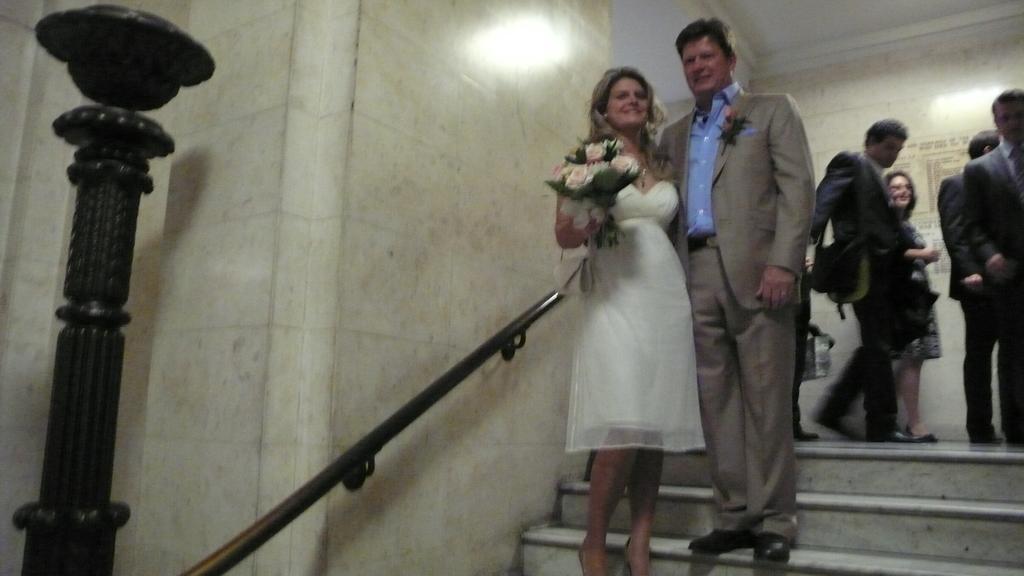Could you give a brief overview of what you see in this image? In this image in the front there are persons standing and smiling. On the left side there is a pole. In the background there are persons walking and standing. On the left side there is a woman standing and holding a flower bouquet in her hand and smiling and there is a wall and a railing. 